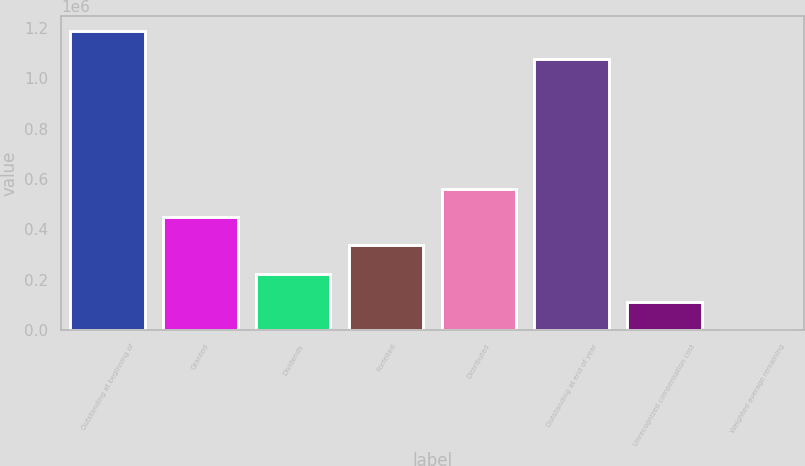Convert chart. <chart><loc_0><loc_0><loc_500><loc_500><bar_chart><fcel>Outstanding at beginning of<fcel>Granted<fcel>Dividends<fcel>Forfeited<fcel>Distributed<fcel>Outstanding at end of year<fcel>Unrecognized compensation cost<fcel>Weighted average remaining<nl><fcel>1.19002e+06<fcel>448403<fcel>224203<fcel>336303<fcel>560502<fcel>1.07792e+06<fcel>112104<fcel>3.8<nl></chart> 